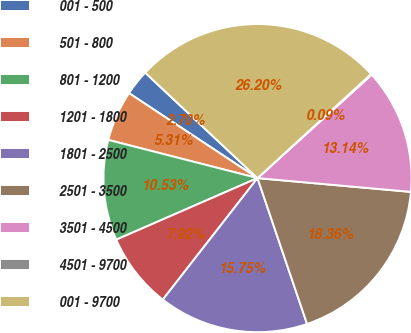<chart> <loc_0><loc_0><loc_500><loc_500><pie_chart><fcel>001 - 500<fcel>501 - 800<fcel>801 - 1200<fcel>1201 - 1800<fcel>1801 - 2500<fcel>2501 - 3500<fcel>3501 - 4500<fcel>4501 - 9700<fcel>001 - 9700<nl><fcel>2.7%<fcel>5.31%<fcel>10.53%<fcel>7.92%<fcel>15.75%<fcel>18.36%<fcel>13.14%<fcel>0.09%<fcel>26.2%<nl></chart> 